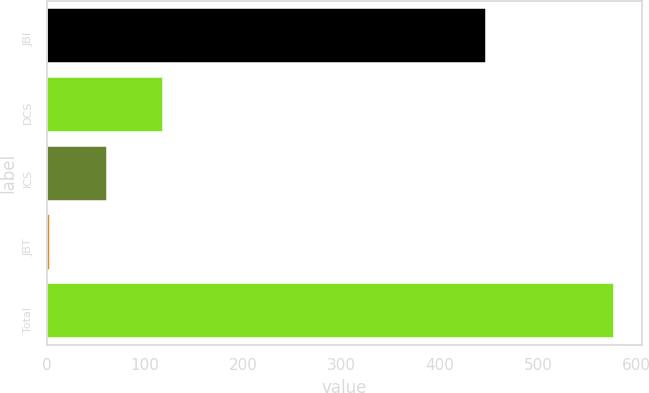Convert chart to OTSL. <chart><loc_0><loc_0><loc_500><loc_500><bar_chart><fcel>JBI<fcel>DCS<fcel>ICS<fcel>JBT<fcel>Total<nl><fcel>447<fcel>118.6<fcel>61.3<fcel>4<fcel>577<nl></chart> 